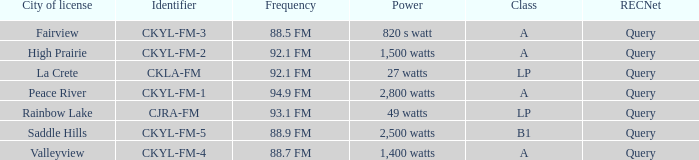What is the City of license with a 88.7 fm frequency Valleyview. 